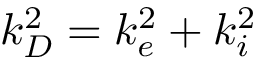Convert formula to latex. <formula><loc_0><loc_0><loc_500><loc_500>k _ { D } ^ { 2 } = k _ { e } ^ { 2 } + k _ { i } ^ { 2 }</formula> 